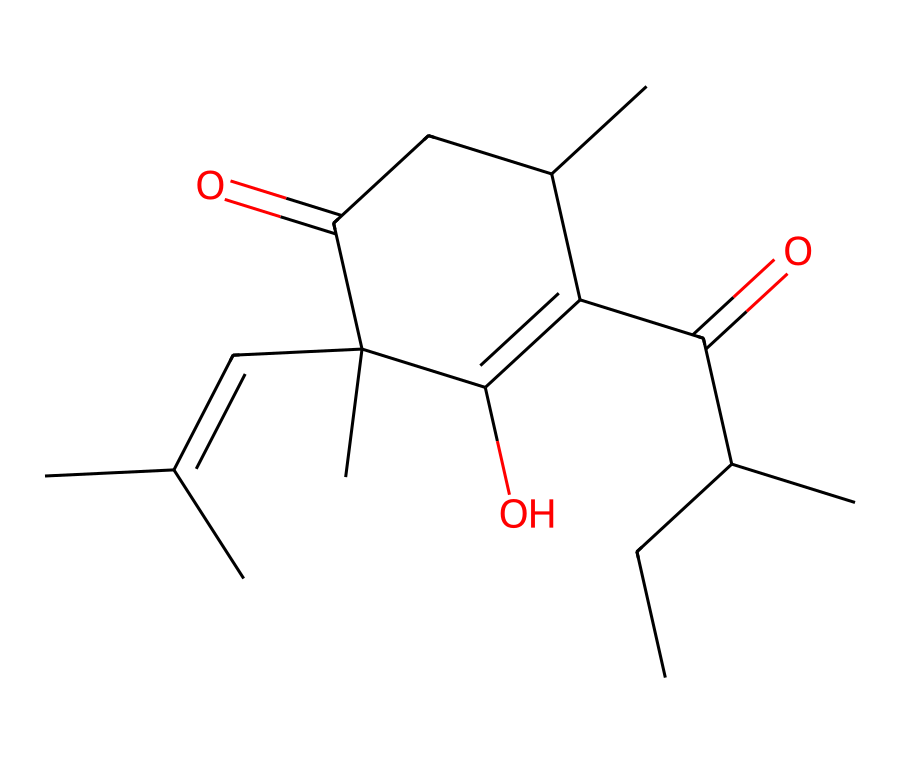What type of chemical structure is this? The chemical is a cycloalkane, as it contains a ring structure with carbon atoms. The 'C' atoms in the SMILES notation indicate this.
Answer: cycloalkane How many carbon atoms are present in this structure? By counting the number of 'C' characters in the SMILES representation, we find that there are 15 carbon atoms total.
Answer: 15 What functional groups are evident in this structure? The structure features ketone (C=O) and alcohol (C(=C1O)) functional groups, indicated by the carbonyl and hydroxyl groups in the structure.
Answer: ketone, alcohol Does this compound contain any double bonds? Yes, there are double bonds present, specifically in the carbon-carbon connections and in the carbonyl groups denoted by 'C=C' and 'C=O'.
Answer: yes What is the molecular formula of this compound? By analyzing the counts from the SMILES representation, we can derive the molecular formula as C15H24O3.
Answer: C15H24O3 How many rings are present in this structure? There is one ring structure directly identified by the 'C1' and subsequent carbon connections, signifying a single cycloalkane ring.
Answer: 1 